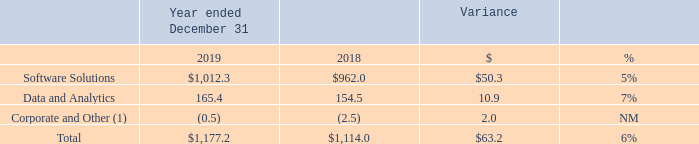Segment Financial Results
Revenues
The following table sets forth revenues by segment for the periods presented (in millions):
(1) Revenues for Corporate and Other represent deferred revenue purchase accounting adjustments recorded in accordance with GAAP.
What did Revenues for Corporate and Other represent? Deferred revenue purchase accounting adjustments recorded in accordance with gaap. What was the total revenue in 2019?
Answer scale should be: million. 1,177.2. What was the dollar variance for software solutions?
Answer scale should be: million. 50.3. How many years did revenue from Data and Analytics exceed $150 million? 2019##2018
Answer: 2. Which years did revenue from Software Solutions exceed $1,000 million? (2019:1,012.3)
Answer: 2019. What was the average total revenue between 2018 and 2019?
Answer scale should be: million. (1,177.2+1,114.0)/2
Answer: 1145.6. 